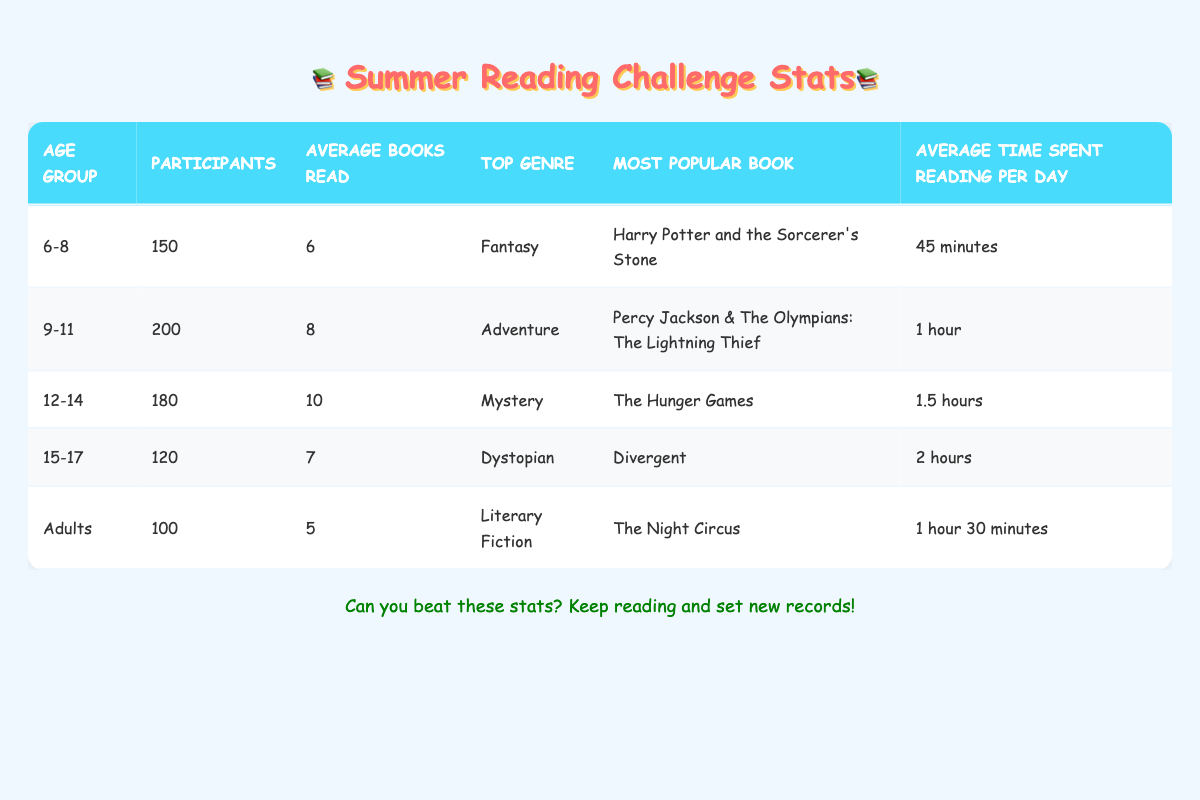What age group had the most participants in the summer reading challenge? The age group with the most participants is "9-11" with 200 participants, which is the highest number in the table.
Answer: 9-11 Which age group read the least number of books on average? The age group "Adults" has the lowest average books read, which is 5 books, compared to the other groups listed.
Answer: Adults What is the total number of participants across all age groups? To find the total number of participants, we add up all participants: 150 + 200 + 180 + 120 + 100 = 750 participants.
Answer: 750 Which age group spent the longest time reading per day on average? The age group "15-17" spent the most time reading, averaging 2 hours per day, compared to other groups in the table.
Answer: 15-17 True or False: The most popular book in the 12-14 age group is "The Hunger Games." The table explicitly states that "The Hunger Games" is noted as the most popular book for the 12-14 age group, thus the statement is true.
Answer: True What is the average number of books read by participants in age groups 6-8 and 9-11 combined? To find the average, we first sum the average books read by both groups: 6 (for 6-8) + 8 (for 9-11) = 14. Then, we divide by 2 to get the average: 14 / 2 = 7.
Answer: 7 Which genre was most popular among the 12-14 age group? According to the data, the top genre for the 12-14 age group is "Mystery," as listed in the table.
Answer: Mystery Calculate the difference in average books read between the 12-14 age group and the Adults. The average books read by the 12-14 age group is 10, while the Adults read an average of 5. The difference is 10 - 5 = 5 books.
Answer: 5 What is the most popular book among the 9-11 age group, and how many participants are there in that group? The most popular book for the 9-11 age group is "Percy Jackson & The Olympians: The Lightning Thief," and there are 200 participants in that age group, as seen in the table.
Answer: Percy Jackson & The Olympians: The Lightning Thief, 200 Which age group has the highest average books read and what is that number? The age group "12-14" has the highest average books read at 10 books, making it the top group in this category.
Answer: 12-14, 10 How many more average books did the 12-14 age group read compared to the 6-8 age group? The 12-14 age group read an average of 10 books, while the 6-8 age group read an average of 6 books. The difference is 10 - 6 = 4 books.
Answer: 4 